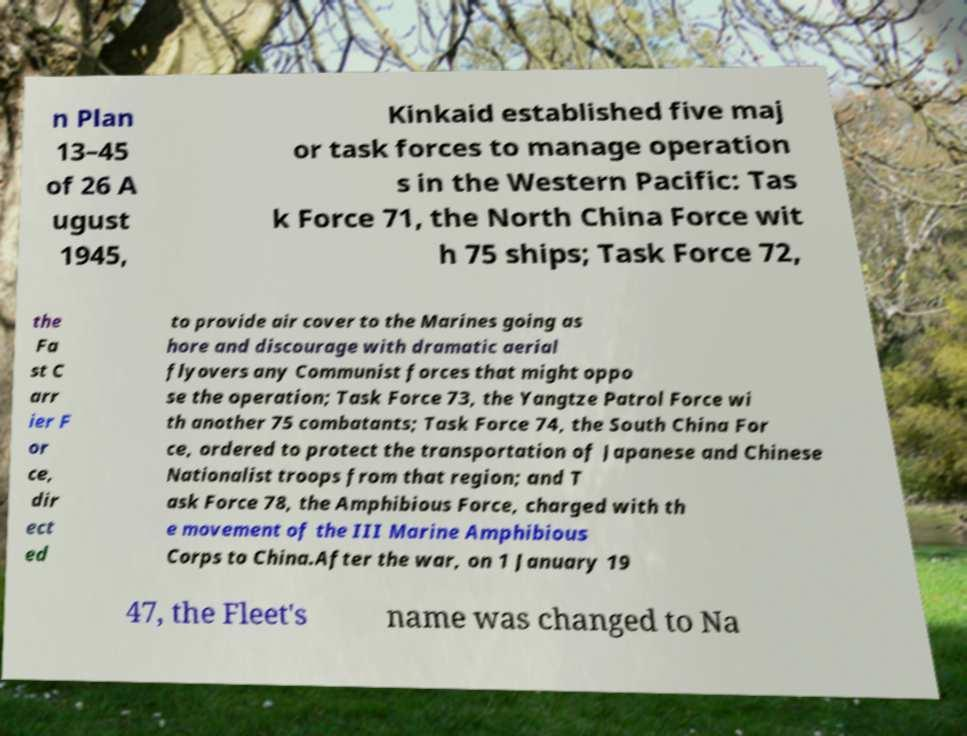Please identify and transcribe the text found in this image. n Plan 13–45 of 26 A ugust 1945, Kinkaid established five maj or task forces to manage operation s in the Western Pacific: Tas k Force 71, the North China Force wit h 75 ships; Task Force 72, the Fa st C arr ier F or ce, dir ect ed to provide air cover to the Marines going as hore and discourage with dramatic aerial flyovers any Communist forces that might oppo se the operation; Task Force 73, the Yangtze Patrol Force wi th another 75 combatants; Task Force 74, the South China For ce, ordered to protect the transportation of Japanese and Chinese Nationalist troops from that region; and T ask Force 78, the Amphibious Force, charged with th e movement of the III Marine Amphibious Corps to China.After the war, on 1 January 19 47, the Fleet's name was changed to Na 